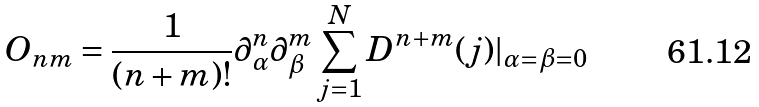Convert formula to latex. <formula><loc_0><loc_0><loc_500><loc_500>O _ { n m } = \frac { 1 } { ( n + m ) ! } \partial _ { \alpha } ^ { n } \partial _ { \beta } ^ { m } \sum _ { j = 1 } ^ { N } D ^ { n + m } ( j ) | _ { \alpha = \beta = 0 }</formula> 